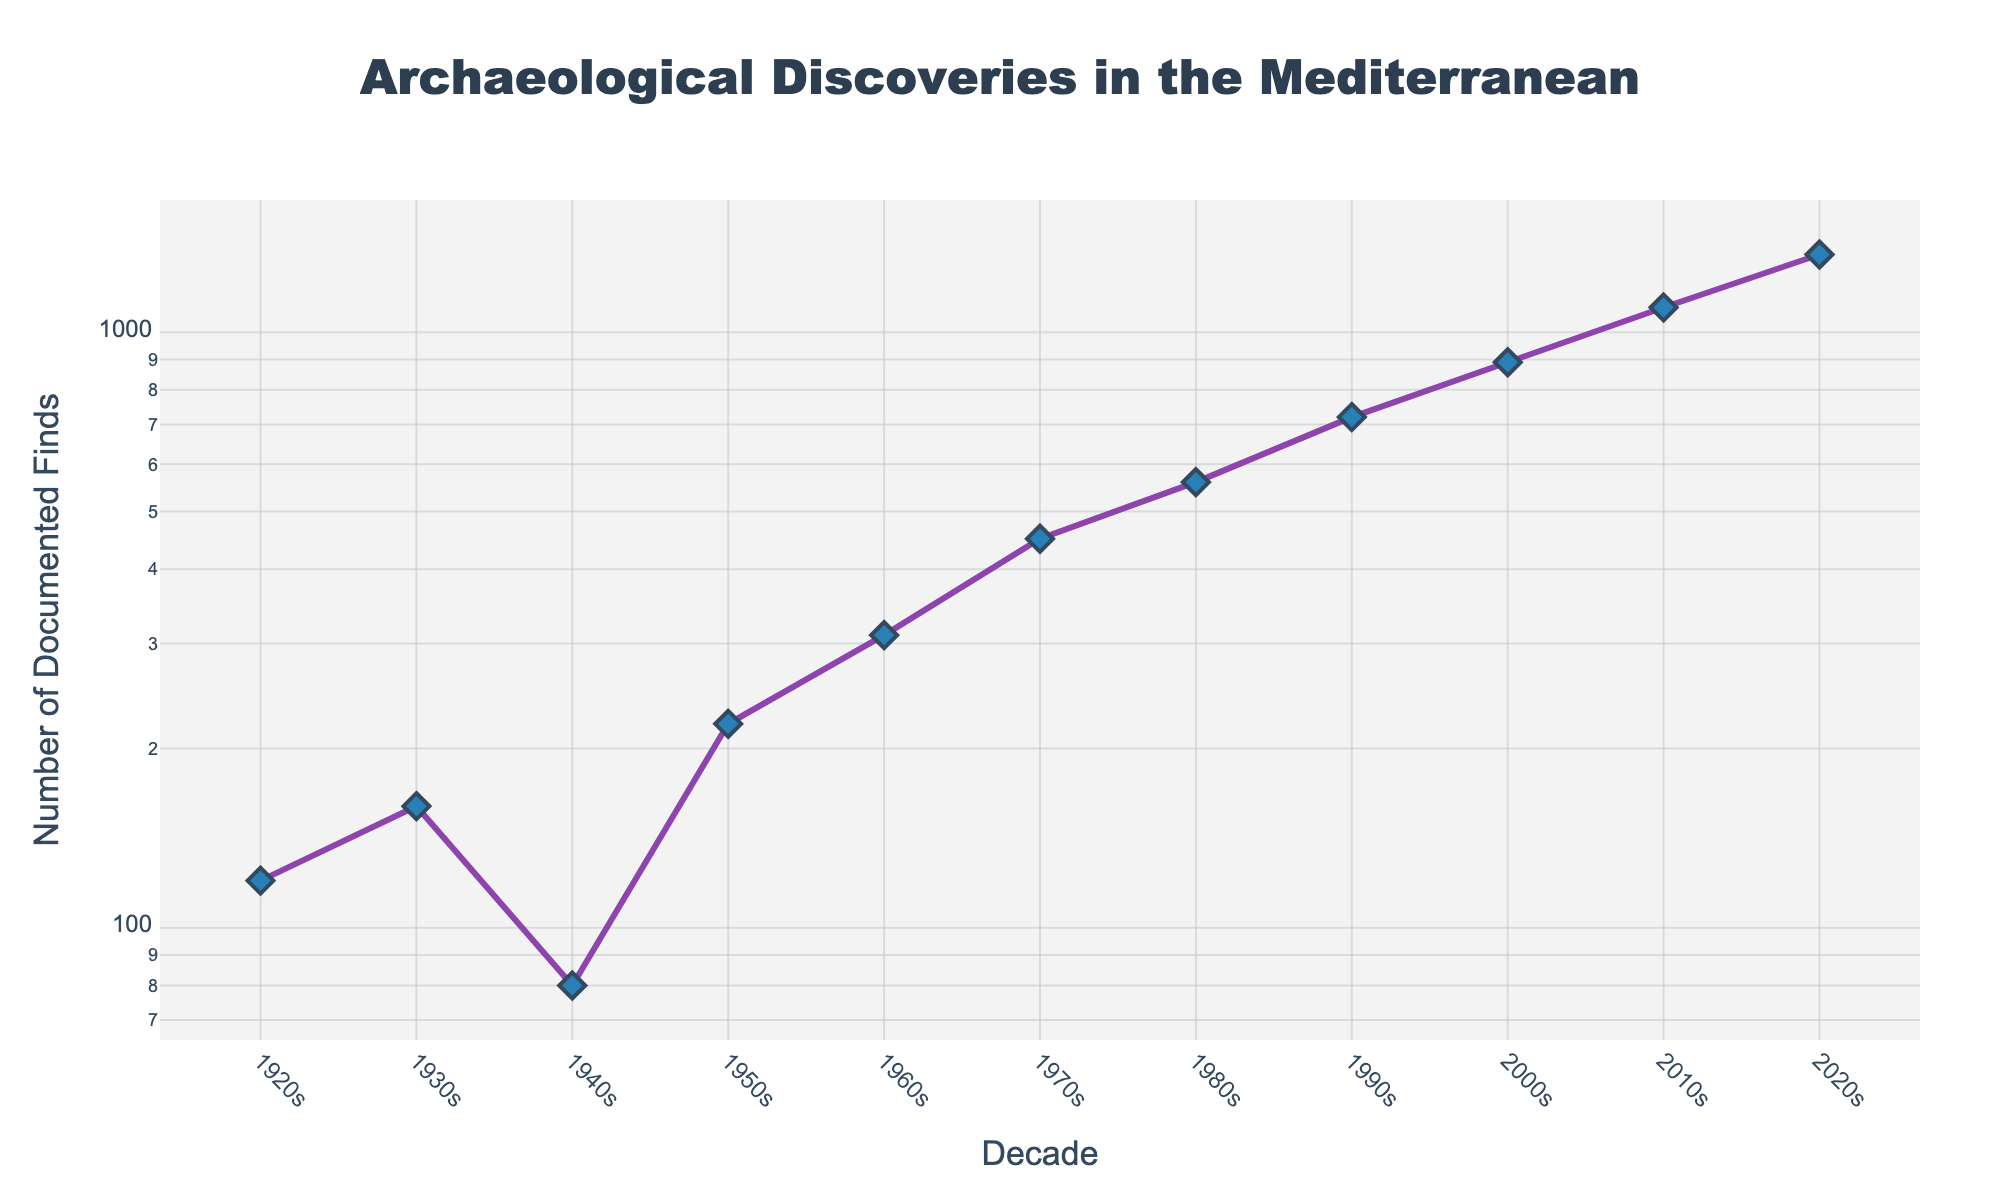what is the title of the figure? The title is located at the top of the figure. It helps to understand the purpose of the plot.
Answer: Archaeological Discoveries in the Mediterranean What is the decade with the highest number of documented finds? The decade with the highest peak in the line plot indicates the maximum number of finds. This can be found by looking at the tallest point of the curve.
Answer: 2020s How does the number of documented finds change from the 1940s to the 1950s? To determine the change, check the number of finds in the 1940s (80) and compare it to the 1950s (220). The difference is calculated as 220 - 80.
Answer: Increased by 140 What is the number of documented finds in the 2010s, and how does it compare to the 2020s? First, find the points for the 2010s (1100) and 2020s (1350). Then compare these values to determine which is higher.
Answer: 1100 finds in the 2010s, and the 2020s has more at 1350 How many decades show a significant increase in the number of finds? By analyzing the overall trend in the line plot, you count the consecutive decades where there is a noticeable increase.
Answer: 8 decades (1920s to 1930s, 1940s to 1950s, 1950s to 1960s, 1960s to 1970s, 1970s to 1980s, 1980s to 1990s, 1990s to 2000s, 2000s to 2010s, and 2010s to 2020s) What is the percentage increase in the number of finds from the 1990s to the 2000s? Calculate using the formula: (Number in 2000s - Number in 1990s) / Number in 1990s * 100. So, (890 - 720) / 720 * 100.
Answer: 23.61% Is there any decade where the number of finds decreased compared to the previous decade? By examining the plot, you can observe the transition from each decade to the next. Notice if any point is lower than the preceding one.
Answer: Yes, from the 1930s to the 1940s Considering the logarithmic scale, what pattern do you observe about the increase in documented finds over the decades? Because the y-axis is logarithmic, consistent increases on the plot represent exponential or multiplicative growth.
Answer: Exponential increase 